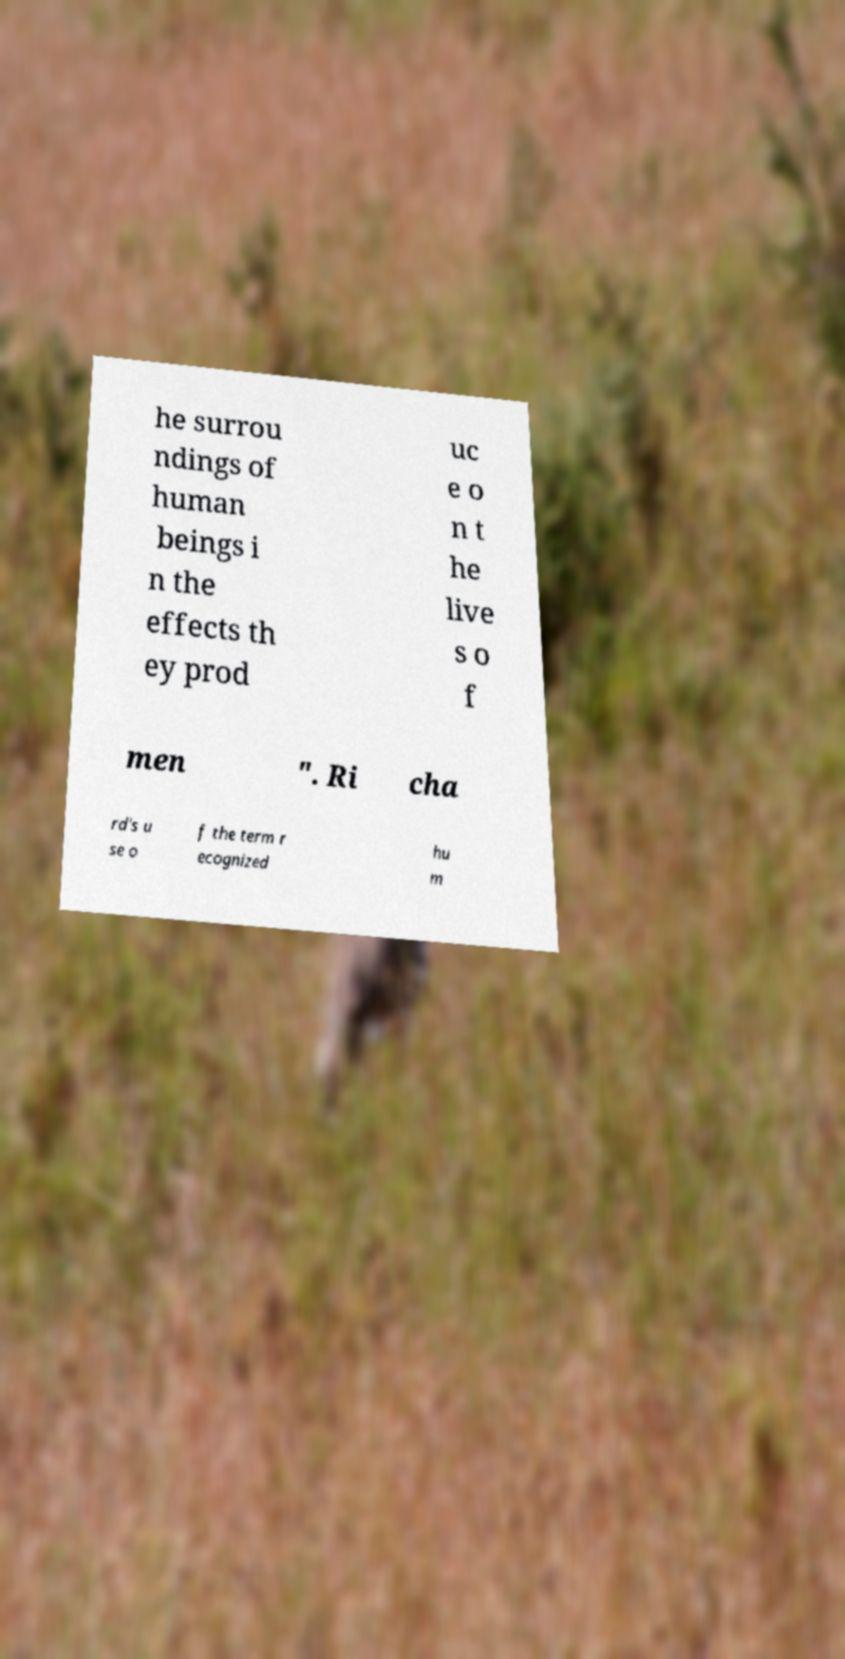Please identify and transcribe the text found in this image. he surrou ndings of human beings i n the effects th ey prod uc e o n t he live s o f men ". Ri cha rd's u se o f the term r ecognized hu m 